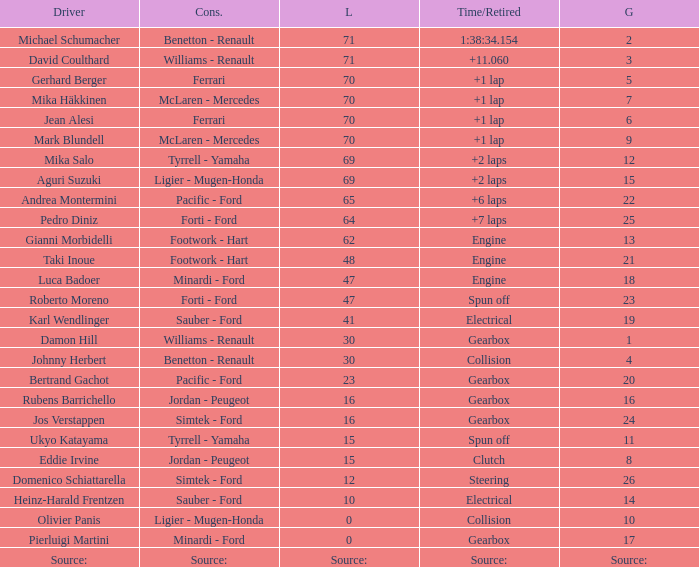David Coulthard was the driver in which grid? 3.0. 